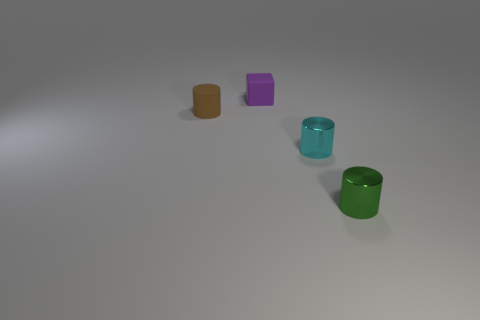Add 4 metallic cylinders. How many objects exist? 8 Subtract all blocks. How many objects are left? 3 Add 2 tiny cubes. How many tiny cubes exist? 3 Subtract 1 brown cylinders. How many objects are left? 3 Subtract all tiny gray rubber cylinders. Subtract all cyan metallic cylinders. How many objects are left? 3 Add 4 rubber cylinders. How many rubber cylinders are left? 5 